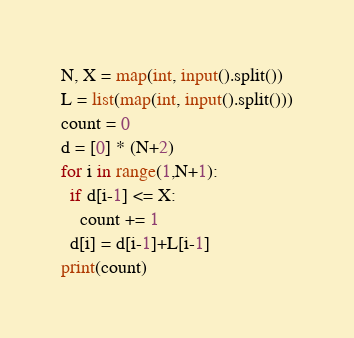<code> <loc_0><loc_0><loc_500><loc_500><_Python_>N, X = map(int, input().split())
L = list(map(int, input().split()))
count = 0
d = [0] * (N+2)
for i in range(1,N+1):
  if d[i-1] <= X:
    count += 1
  d[i] = d[i-1]+L[i-1]
print(count)</code> 